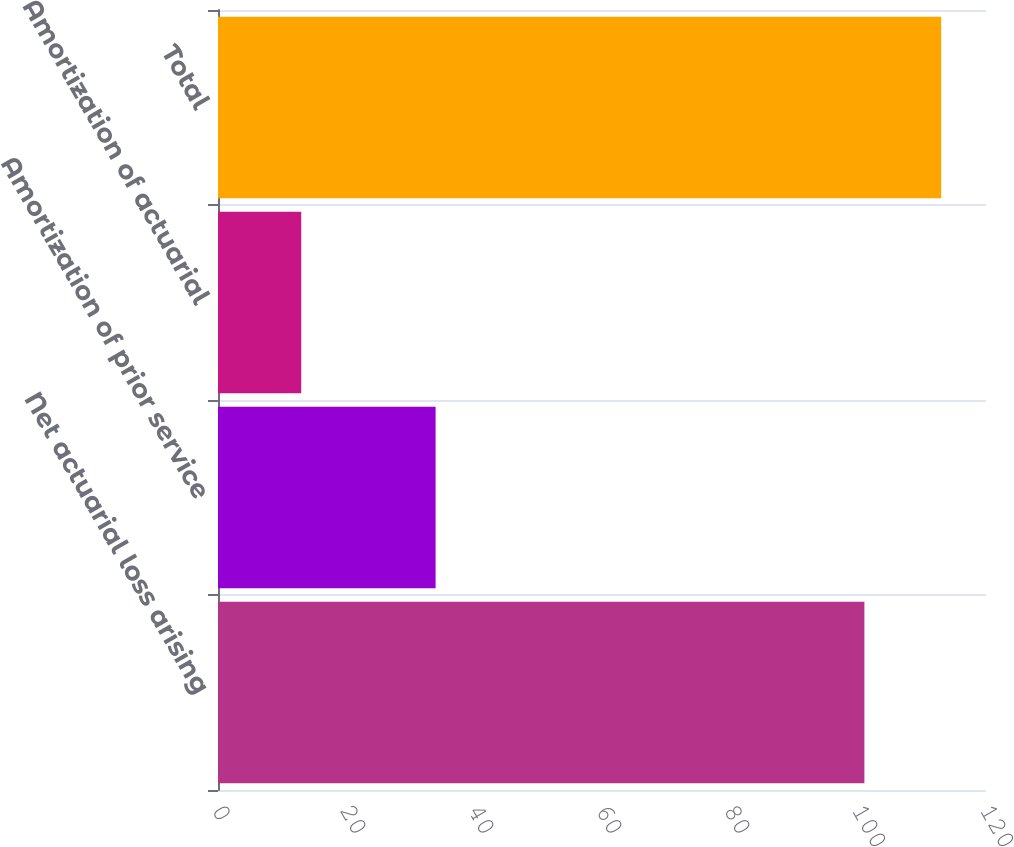<chart> <loc_0><loc_0><loc_500><loc_500><bar_chart><fcel>Net actuarial loss arising<fcel>Amortization of prior service<fcel>Amortization of actuarial<fcel>Total<nl><fcel>101<fcel>34<fcel>13<fcel>113<nl></chart> 